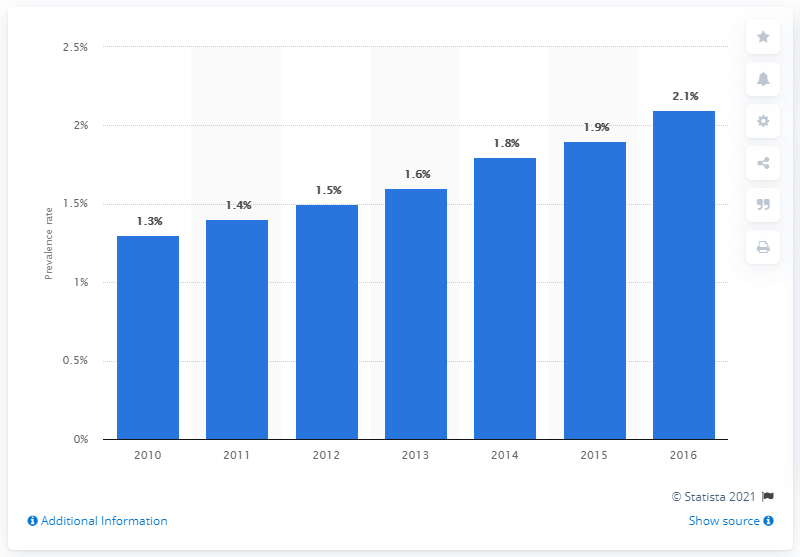Point out several critical features in this image. The prevalence of obesity among adults in Vietnam was 2.1% in 2016. 